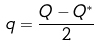<formula> <loc_0><loc_0><loc_500><loc_500>q = \frac { Q - Q ^ { \ast } } { 2 }</formula> 